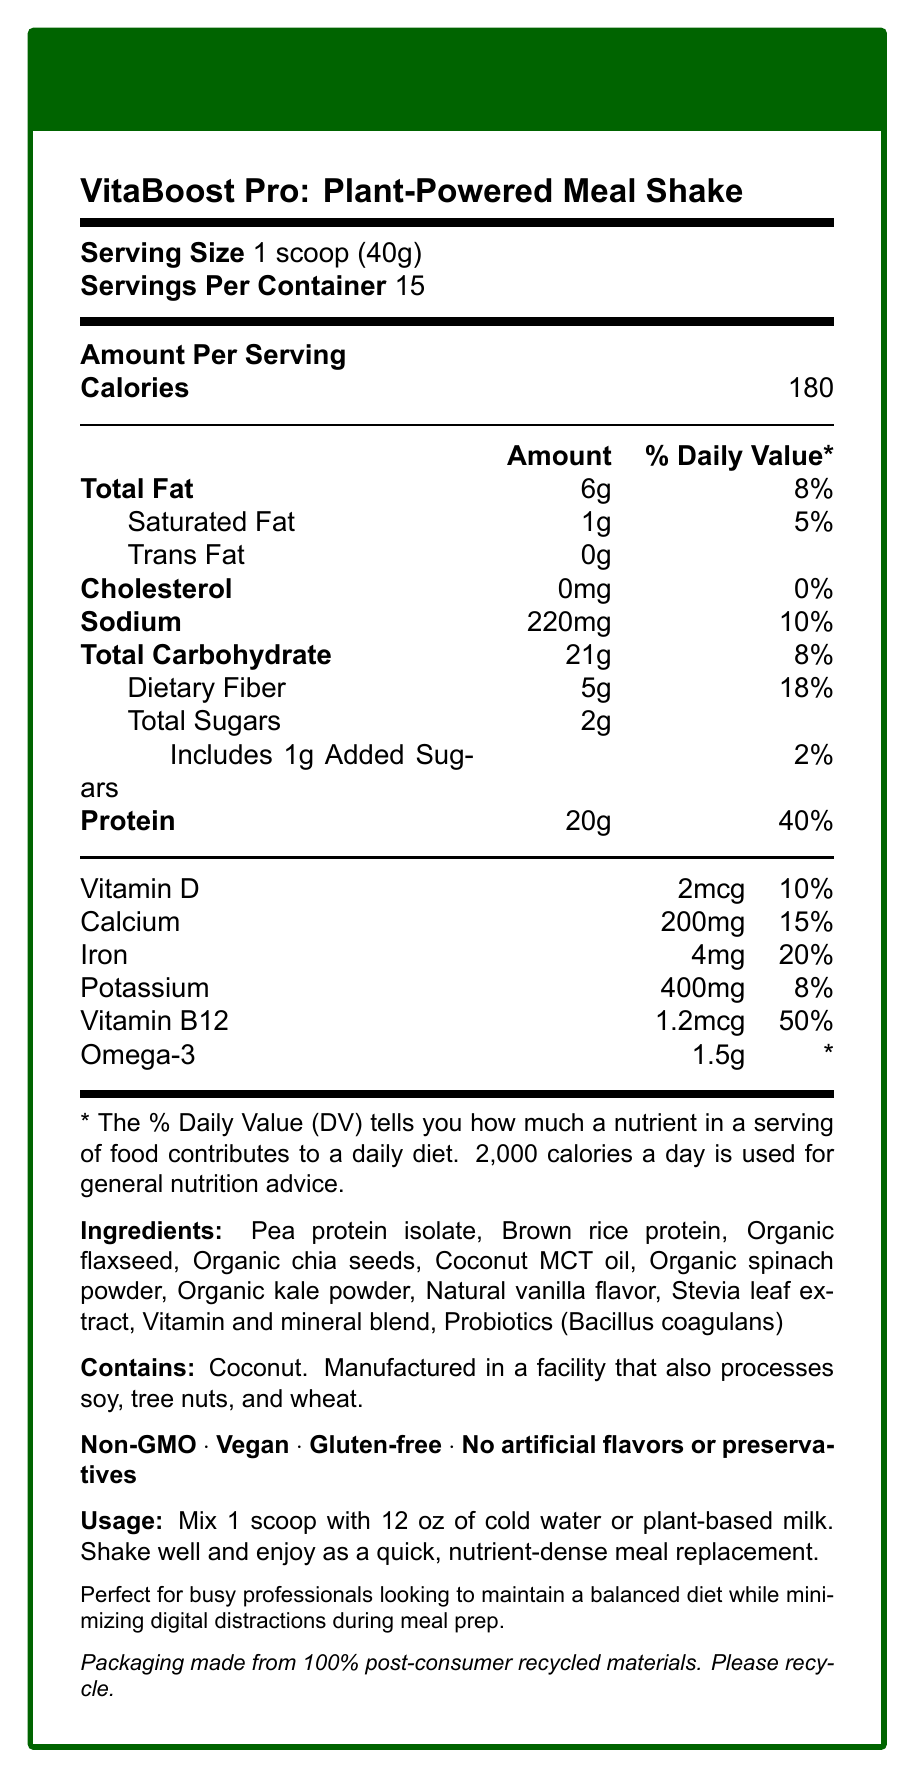How many servings are in a container of VitaBoost Pro? The document states "Servings Per Container: 15."
Answer: 15 What is the serving size for VitaBoost Pro? The document lists the serving size as "1 scoop (40g)."
Answer: 1 scoop (40g) What is the total fat content per serving? The document specifies "Total Fat: 6g."
Answer: 6g Does VitaBoost Pro contain any trans fat? The document states "Trans Fat: 0g."
Answer: No What is the percentage of the Daily Value for dietary fiber provided in one serving? The document lists "Dietary Fiber: 5g, Daily Value: 18%."
Answer: 18% How much protein does one serving contain? The document specifies "Protein: 20g."
Answer: 20g What types of ingredients are included in VitaBoost Pro? The document provides a detailed list of ingredients in the VitaBoost Pro.
Answer: Pea protein isolate, Brown rice protein, Organic flaxseed, Organic chia seeds, Coconut MCT oil, Organic spinach powder, Organic kale powder, Natural vanilla flavor, Stevia leaf extract, Vitamin and mineral blend, Probiotics (Bacillus coagulans) Which claim statements are associated with VitaBoost Pro? A. Organic, Dairy-Free, Sugar-Free B. Non-GMO, Vegan, Gluten-Free, No artificial flavors or preservatives C. Low-Fat, High-Protein, Sugar-Free D. All-Natural, Dairy-Free, No added sugars The document lists the claim statements as "Non-GMO, Vegan, Gluten-free, No artificial flavors or preservatives."
Answer: B What is the main purpose of VitaBoost Pro according to the lifestyle note? The document states, "Perfect for busy professionals looking to maintain a balanced diet while minimizing digital distractions during meal prep."
Answer: To maintain a balanced diet while minimizing digital distractions during meal prep Are there any allergens contained in VitaBoost Pro? The document states, "Contains coconut. Manufactured in a facility that also processes soy, tree nuts, and wheat."
Answer: Yes Which nutrient provides the highest percentage of the Daily Value in one serving? A. Calcium B. Vitamin D C. Protein D. Potassium The document lists the Daily Value percentages, with Protein at 40%, which is the highest among the referenced nutrients.
Answer: C What are the usage instructions for VitaBoost Pro? The document provides detailed instructions on how to consume the product under "Usage."
Answer: Mix 1 scoop with 12 oz of cold water or plant-based milk. Shake well and enjoy as a quick, nutrient-dense meal replacement. Does VitaBoost Pro contain any cholesterol? The document specifies "Cholesterol: 0mg."
Answer: No Summarize the main points of the VitaBoost Pro nutrition facts label. The document provides comprehensive details about the nutritional content, ingredients, usage, allergen information, and the overall purpose of the meal shake.
Answer: VitaBoost Pro is a plant-powered meal shake designed for busy professionals, providing 180 calories per serving with notable amounts of protein (20g), dietary fiber (5g), and various vitamins and minerals. It is non-GMO, vegan, gluten-free, and contains no artificial flavors or preservatives. The shake also includes ingredients such as pea protein isolate, organic flaxseed, and probiotics. It is meant to be mixed with cold water or plant-based milk and helps maintain a balanced diet while reducing digital distractions during meals. What is the amount of omega-3 per serving? The document lists "Omega-3: 1.5g."
Answer: 1.5g What type of protein source is used in VitaBoost Pro? The document lists these ingredients explicitly as protein sources.
Answer: Pea protein isolate and Brown rice protein Does the document mention any specific health benefits of the probiotics included in VitaBoost Pro? The document lists probiotics (Bacillus coagulans) as an ingredient but does not mention specific health benefits.
Answer: No 